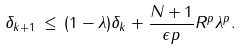Convert formula to latex. <formula><loc_0><loc_0><loc_500><loc_500>\delta _ { k + 1 } \, \leq \, ( 1 - \lambda ) \delta _ { k } + \frac { N + 1 } { \epsilon p } R ^ { p } \lambda ^ { p } .</formula> 